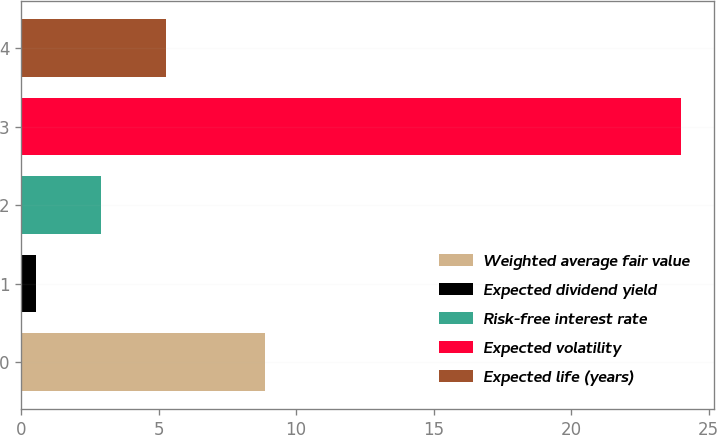Convert chart. <chart><loc_0><loc_0><loc_500><loc_500><bar_chart><fcel>Weighted average fair value<fcel>Expected dividend yield<fcel>Risk-free interest rate<fcel>Expected volatility<fcel>Expected life (years)<nl><fcel>8.86<fcel>0.55<fcel>2.9<fcel>24<fcel>5.25<nl></chart> 